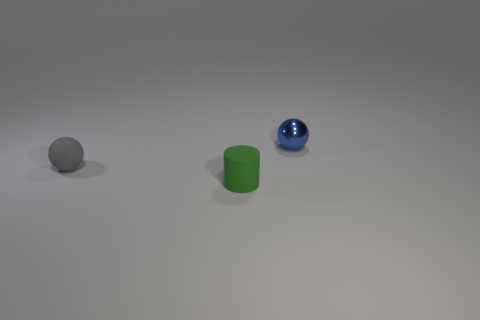Is the number of green things in front of the small metallic sphere greater than the number of small blue cylinders?
Offer a terse response. Yes. Do the small matte object behind the small green matte cylinder and the green matte object have the same shape?
Your response must be concise. No. What number of cyan objects are small balls or tiny cylinders?
Your response must be concise. 0. Are there more small gray balls than yellow metal objects?
Offer a very short reply. Yes. There is a sphere that is the same size as the gray matte thing; what color is it?
Offer a terse response. Blue. How many cubes are blue metallic objects or tiny green objects?
Make the answer very short. 0. Is the shape of the blue object the same as the gray matte thing left of the small rubber cylinder?
Offer a terse response. Yes. How many other green objects are the same size as the green object?
Provide a succinct answer. 0. There is a thing that is left of the green matte cylinder; does it have the same shape as the rubber thing that is in front of the tiny gray matte thing?
Ensure brevity in your answer.  No. There is a rubber object that is to the right of the small rubber object that is left of the small cylinder; what color is it?
Offer a terse response. Green. 